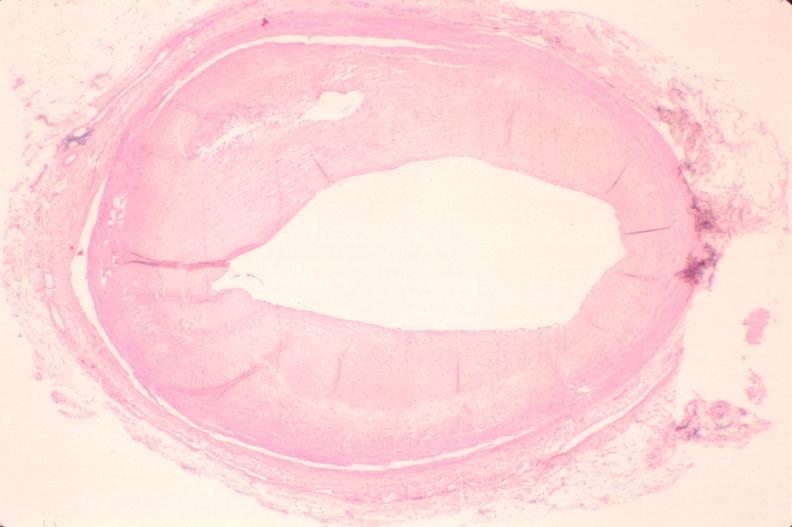s cardiovascular present?
Answer the question using a single word or phrase. Yes 